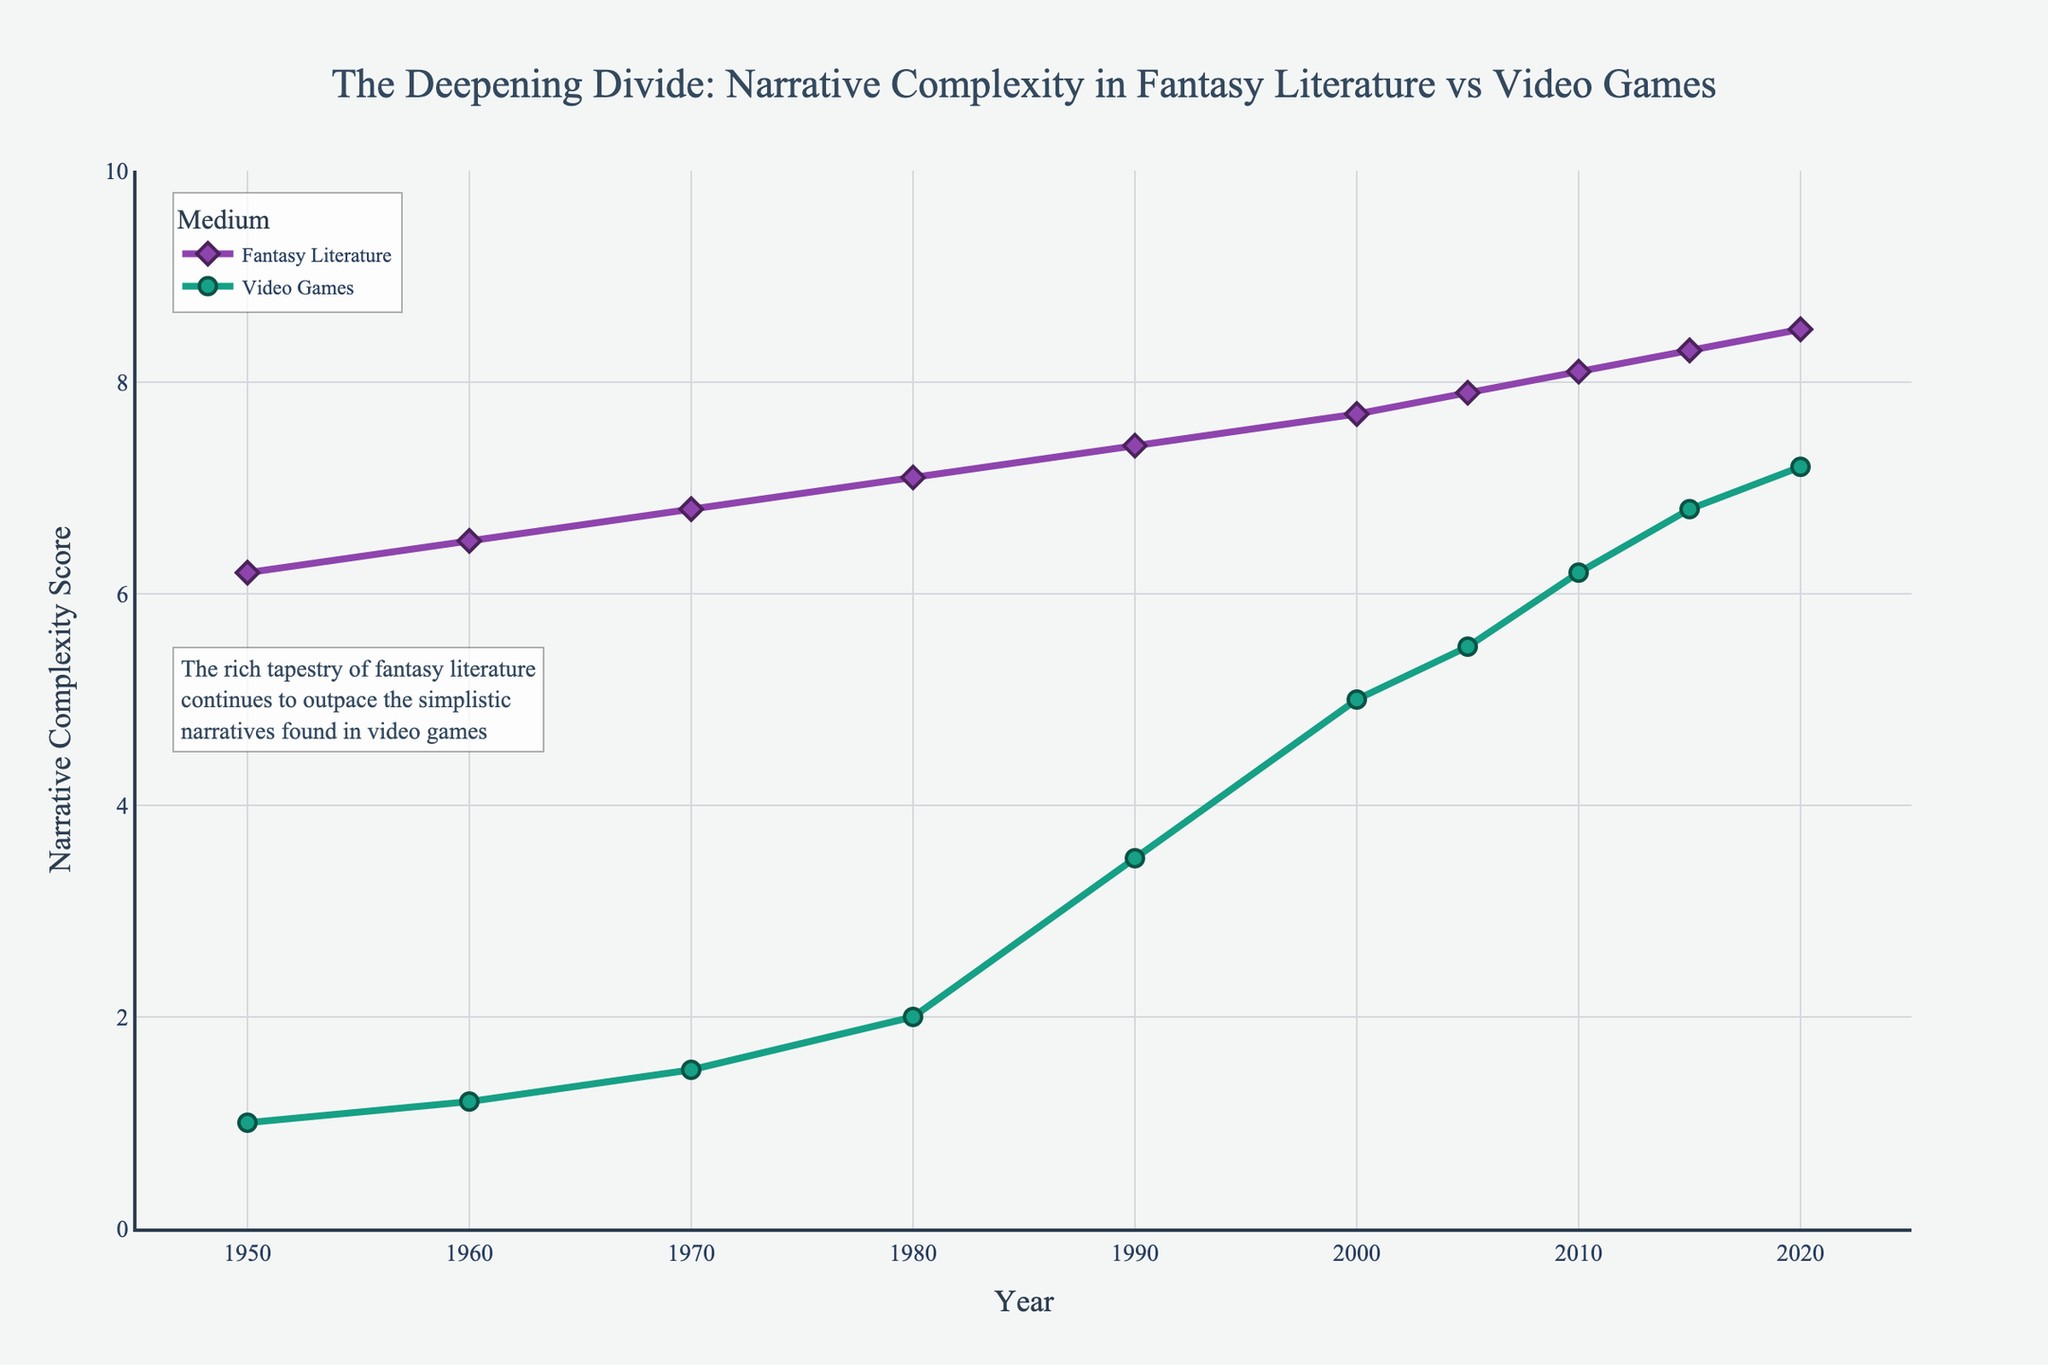What's the difference in narrative complexity score between fantasy literature and video games in 2020? Look at the values for the year 2020: Fantasy Literature is 8.5 and Video Games is 7.2. Subtract 7.2 from 8.5.
Answer: 1.3 How many years did it take for video game storylines to reach a complexity score of 6.0 or higher? Review the video game storyline complexity scores and identify the first year with a score of 6.0 or higher, which is 2010. The years between 1950 and 2010 are 60 years.
Answer: 60 What is the average narrative complexity score of fantasy literature from 1950 to 2020? Add up all the values for fantasy literature narrative complexity scores from 1950 to 2020: 6.2 + 6.5 + 6.8 + 7.1 + 7.4 + 7.7 + 7.9 + 8.1 + 8.3 + 8.5, which equals 74.5, then divide by the number of years (10).
Answer: 7.45 Which year saw the greatest increase in video game storyline complexity? Calculate the year-to-year differences in the video game storyline complexity scores. The largest difference occurs between 1980 (2.0) and 1990 (3.5), which is 1.5.
Answer: Between 1980 and 1990 Are there any years when the narrative complexity scores for both fantasy literature and video games show no increase compared to the previous year? Compare each year's scores to the previous year's scores for both series. All years show an increase in narrative complexity scores for both mediums.
Answer: No What year did video game storylines first exceed a complexity score of 5.0? Review the video game storyline complexity scores and identify the first year with a score exceeding 5.0, which is 2000 with a score of 5.0.
Answer: 2000 Compare the trend lines in terms of their steepness. Which medium shows a steeper increase in complexity over time? The video game trend line shows a steeper increase when compared to fantasy literature, particularly notable from 1990 onward.
Answer: Video games How does the narrative complexity score of fantasy literature in 1980 compare to that of video games in 2010? Refer to the values for 1980 in fantasy literature (7.1) and 2010 in video games (6.2) and compare them.
Answer: 7.1 is greater than 6.2 Between which years did fantasy literature experience the smallest increase in narrative complexity? Calculate the year-to-year differences in fantasy literature narrative complexity scores to identify the smallest difference, which occurs between 2005 (7.9) and 2010 (8.1) with an increase of 0.2.
Answer: Between 2005 and 2010 What is the difference in narrative complexity scores between fantasy literature and video games in 1990 and how does this compare to the difference in 2020? For 1990, the difference is 7.4 (literature) - 3.5 (games) = 3.9. For 2020, the difference is 8.5 (literature) - 7.2 (games) = 1.3. Therefore, 3.9 - 1.3 = 2.6, indicating a 2.6 reduction in the difference over these years.
Answer: 2.6 reduction 